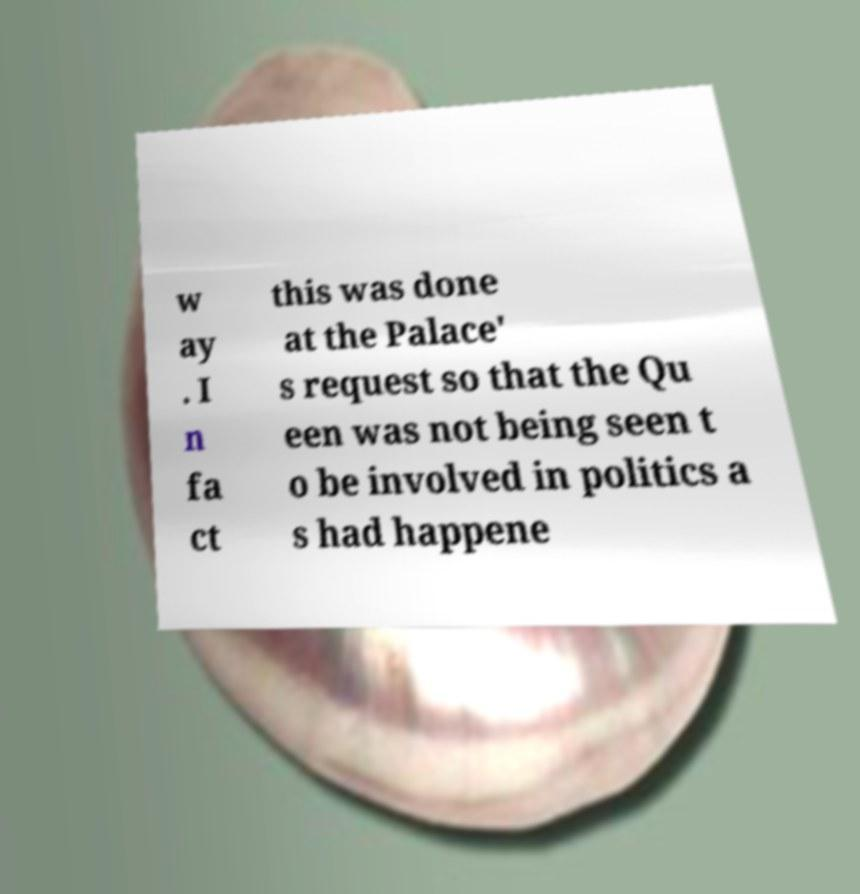What messages or text are displayed in this image? I need them in a readable, typed format. w ay . I n fa ct this was done at the Palace' s request so that the Qu een was not being seen t o be involved in politics a s had happene 